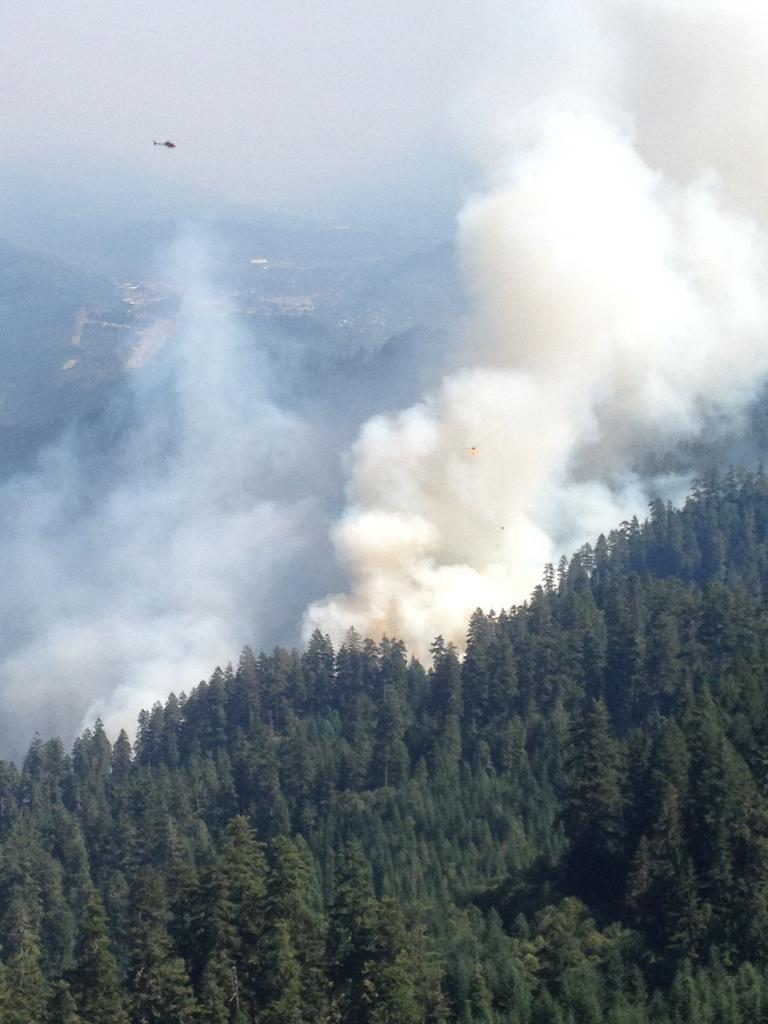What type of natural formation can be seen in the image? There is a group of trees in the image. What other geographical feature is present in the image? There are mountains in the image. What mode of transportation is visible in the image? There is a helicopter in the image. What part of the environment is visible in the image? The sky is visible in the image. What type of flesh can be seen on the trees in the image? There is no flesh present on the trees in the image; they are made of wood and leaves. Is there a camp visible in the image? There is no camp present in the image. 